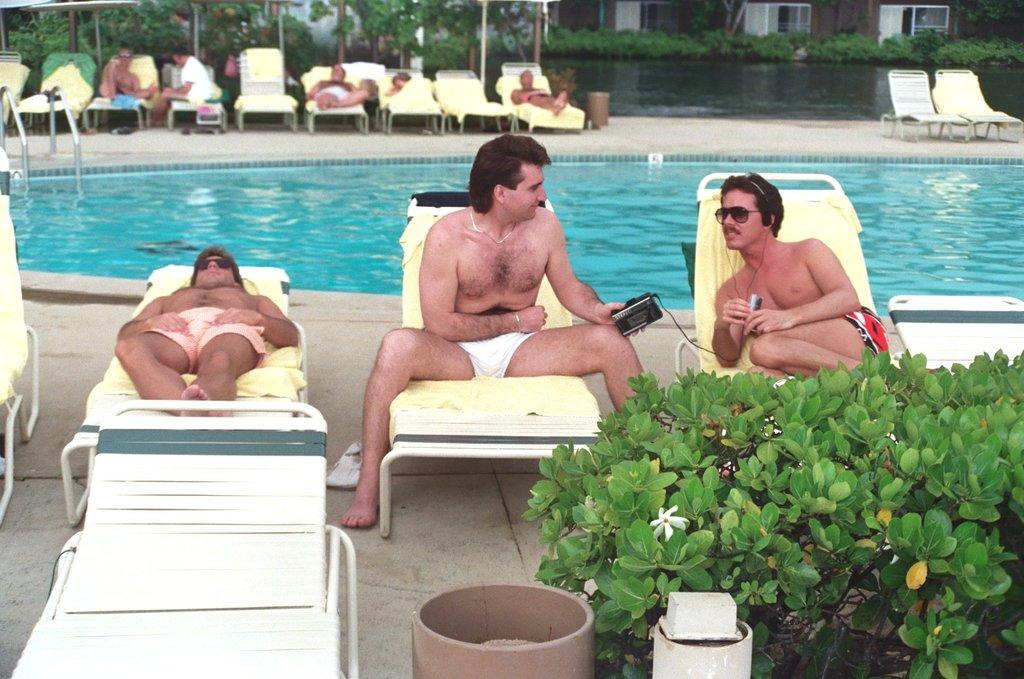What is the primary element in the image? There is water in the image. What are the people in the image doing? The people are sitting on chairs on chairs on the ground. What type of vegetation can be seen in the image? Plants and flowers are visible in the image. What material are the poles made of in the image? The poles in the image are made of metal. Can you describe any other objects present in the image? There are other objects in the image, but their specific details are not mentioned in the provided facts. What type of hobbies do the people sitting on chairs have in the image? There is no information about the people's hobbies in the image or the provided facts. 